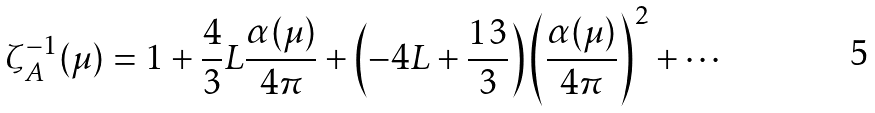<formula> <loc_0><loc_0><loc_500><loc_500>\zeta _ { A } ^ { - 1 } ( \mu ) = 1 + \frac { 4 } { 3 } L \frac { \alpha ( \mu ) } { 4 \pi } + \left ( - 4 L + \frac { 1 3 } { 3 } \right ) \left ( \frac { \alpha ( \mu ) } { 4 \pi } \right ) ^ { 2 } + \cdots</formula> 